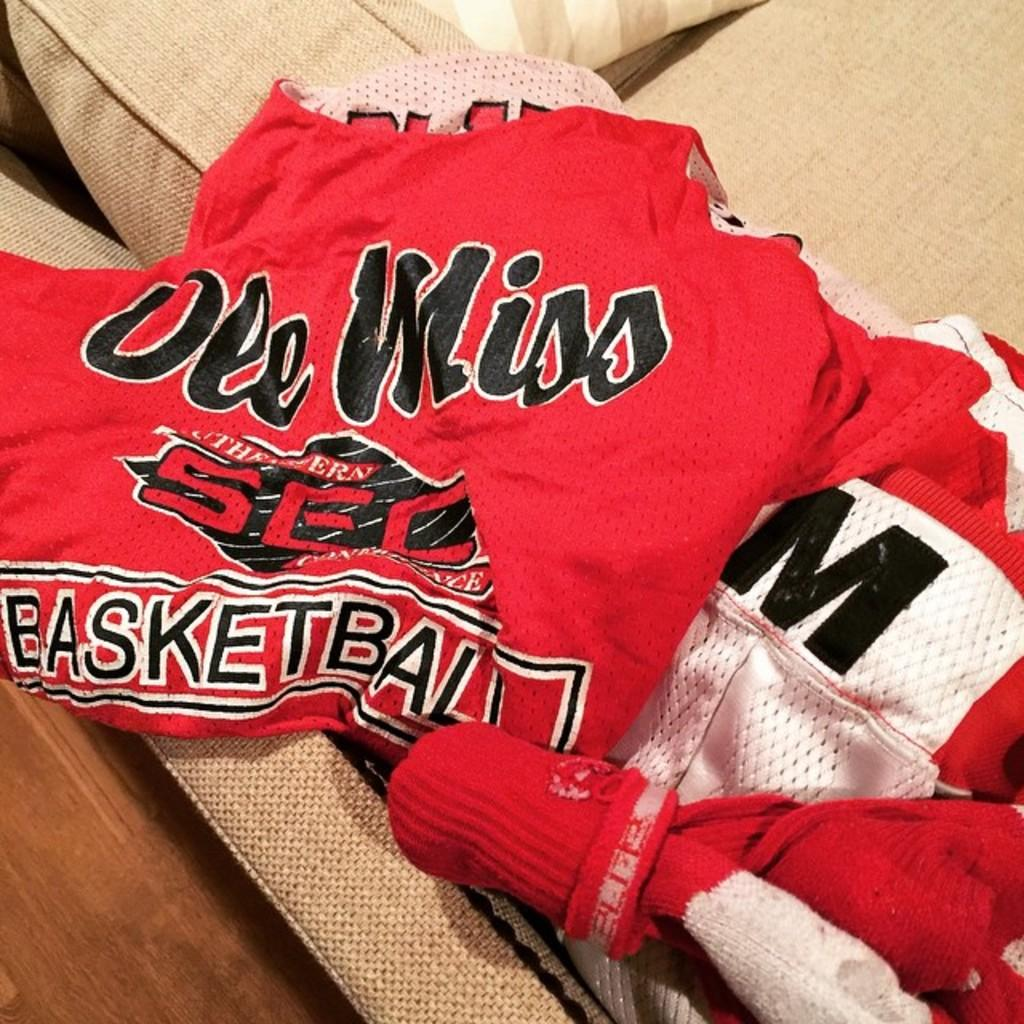<image>
Render a clear and concise summary of the photo. An Ole Miss basketball jersey is laying on a couch. 